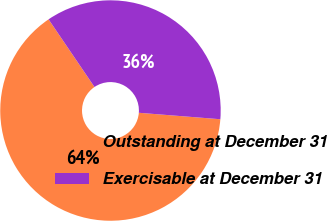<chart> <loc_0><loc_0><loc_500><loc_500><pie_chart><fcel>Outstanding at December 31<fcel>Exercisable at December 31<nl><fcel>64.25%<fcel>35.75%<nl></chart> 